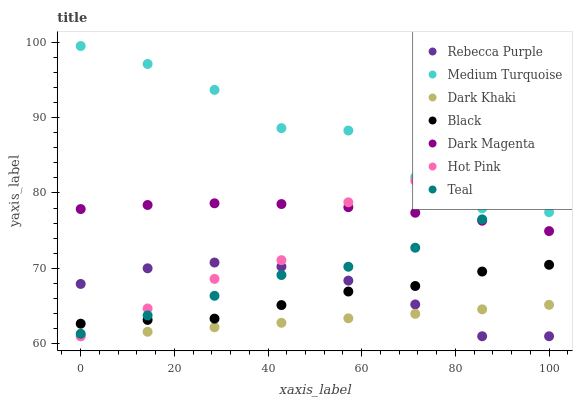Does Dark Khaki have the minimum area under the curve?
Answer yes or no. Yes. Does Medium Turquoise have the maximum area under the curve?
Answer yes or no. Yes. Does Dark Magenta have the minimum area under the curve?
Answer yes or no. No. Does Dark Magenta have the maximum area under the curve?
Answer yes or no. No. Is Dark Khaki the smoothest?
Answer yes or no. Yes. Is Medium Turquoise the roughest?
Answer yes or no. Yes. Is Dark Magenta the smoothest?
Answer yes or no. No. Is Dark Magenta the roughest?
Answer yes or no. No. Does Hot Pink have the lowest value?
Answer yes or no. Yes. Does Dark Magenta have the lowest value?
Answer yes or no. No. Does Medium Turquoise have the highest value?
Answer yes or no. Yes. Does Dark Magenta have the highest value?
Answer yes or no. No. Is Rebecca Purple less than Medium Turquoise?
Answer yes or no. Yes. Is Dark Magenta greater than Black?
Answer yes or no. Yes. Does Dark Khaki intersect Rebecca Purple?
Answer yes or no. Yes. Is Dark Khaki less than Rebecca Purple?
Answer yes or no. No. Is Dark Khaki greater than Rebecca Purple?
Answer yes or no. No. Does Rebecca Purple intersect Medium Turquoise?
Answer yes or no. No. 